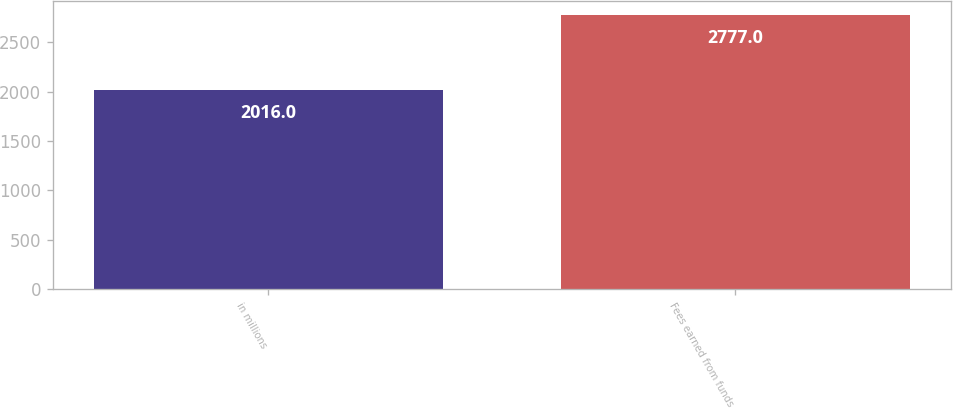<chart> <loc_0><loc_0><loc_500><loc_500><bar_chart><fcel>in millions<fcel>Fees earned from funds<nl><fcel>2016<fcel>2777<nl></chart> 